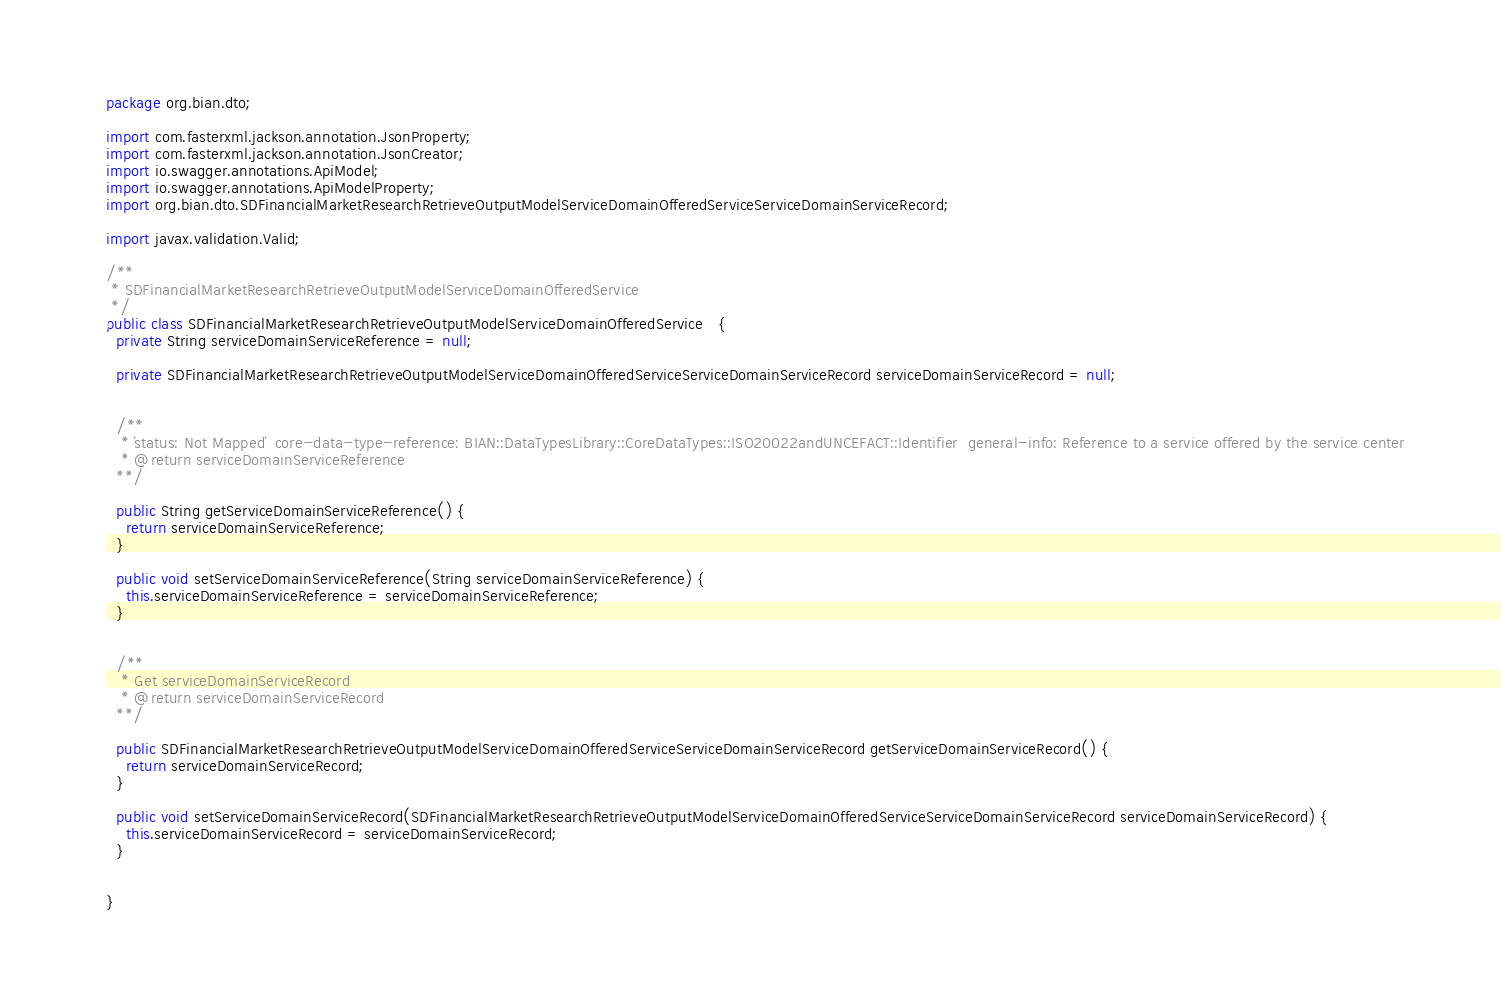<code> <loc_0><loc_0><loc_500><loc_500><_Java_>package org.bian.dto;

import com.fasterxml.jackson.annotation.JsonProperty;
import com.fasterxml.jackson.annotation.JsonCreator;
import io.swagger.annotations.ApiModel;
import io.swagger.annotations.ApiModelProperty;
import org.bian.dto.SDFinancialMarketResearchRetrieveOutputModelServiceDomainOfferedServiceServiceDomainServiceRecord;

import javax.validation.Valid;
  
/**
 * SDFinancialMarketResearchRetrieveOutputModelServiceDomainOfferedService
 */
public class SDFinancialMarketResearchRetrieveOutputModelServiceDomainOfferedService   {
  private String serviceDomainServiceReference = null;

  private SDFinancialMarketResearchRetrieveOutputModelServiceDomainOfferedServiceServiceDomainServiceRecord serviceDomainServiceRecord = null;


  /**
   * `status: Not Mapped`  core-data-type-reference: BIAN::DataTypesLibrary::CoreDataTypes::ISO20022andUNCEFACT::Identifier  general-info: Reference to a service offered by the service center 
   * @return serviceDomainServiceReference
  **/

  public String getServiceDomainServiceReference() {
    return serviceDomainServiceReference;
  }

  public void setServiceDomainServiceReference(String serviceDomainServiceReference) {
    this.serviceDomainServiceReference = serviceDomainServiceReference;
  }


  /**
   * Get serviceDomainServiceRecord
   * @return serviceDomainServiceRecord
  **/

  public SDFinancialMarketResearchRetrieveOutputModelServiceDomainOfferedServiceServiceDomainServiceRecord getServiceDomainServiceRecord() {
    return serviceDomainServiceRecord;
  }

  public void setServiceDomainServiceRecord(SDFinancialMarketResearchRetrieveOutputModelServiceDomainOfferedServiceServiceDomainServiceRecord serviceDomainServiceRecord) {
    this.serviceDomainServiceRecord = serviceDomainServiceRecord;
  }


}

</code> 